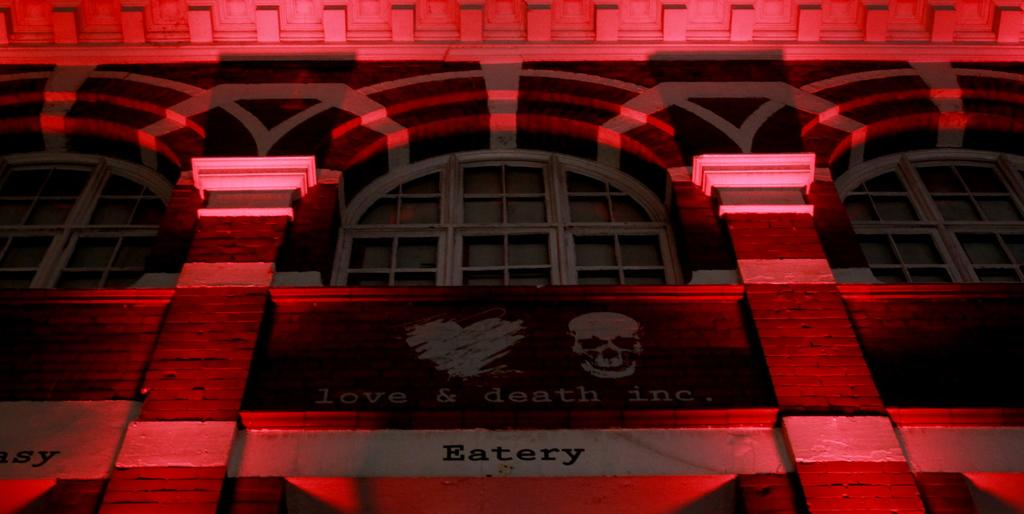What is the main subject of the image? The main subject of the image is a building. What can be seen on the building? The building has text on it. What architectural feature is present on the building? The building has windows. What type of weather can be seen in the image? The provided facts do not mention any weather conditions, so it cannot be determined from the image. Is there a crook present in the image? There is no crook mentioned or visible in the image. 